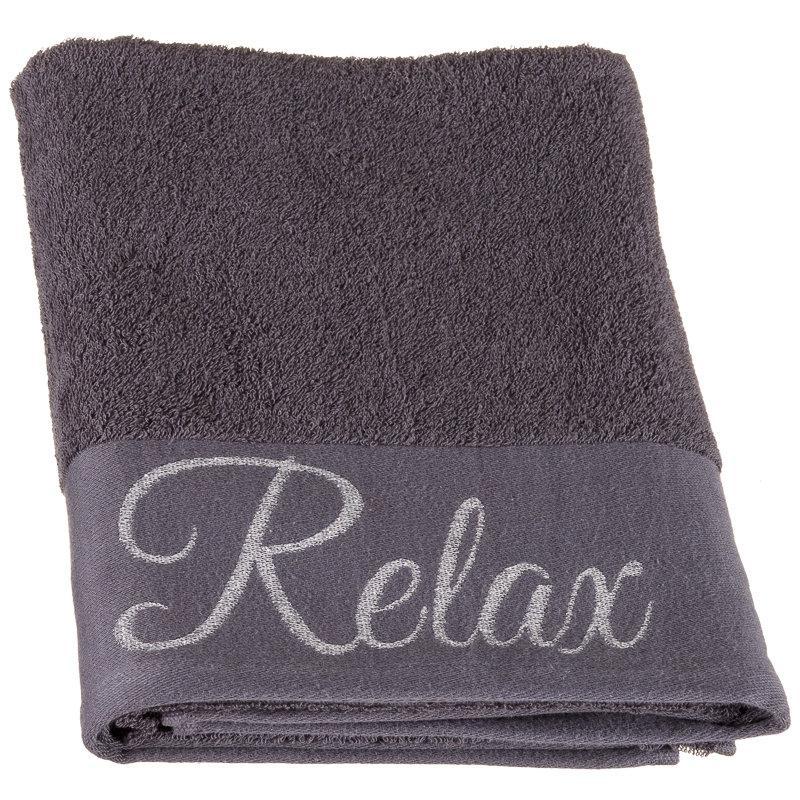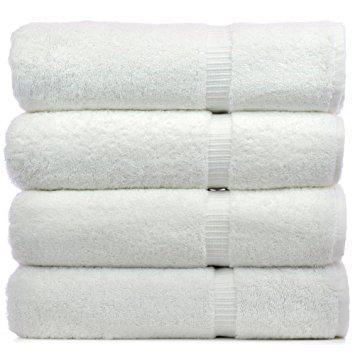The first image is the image on the left, the second image is the image on the right. Analyze the images presented: Is the assertion "One image features a stack of exactly three solid white folded towels." valid? Answer yes or no. No. The first image is the image on the left, the second image is the image on the right. For the images displayed, is the sentence "Three white towels are stacked on each other in the image on the left." factually correct? Answer yes or no. No. 